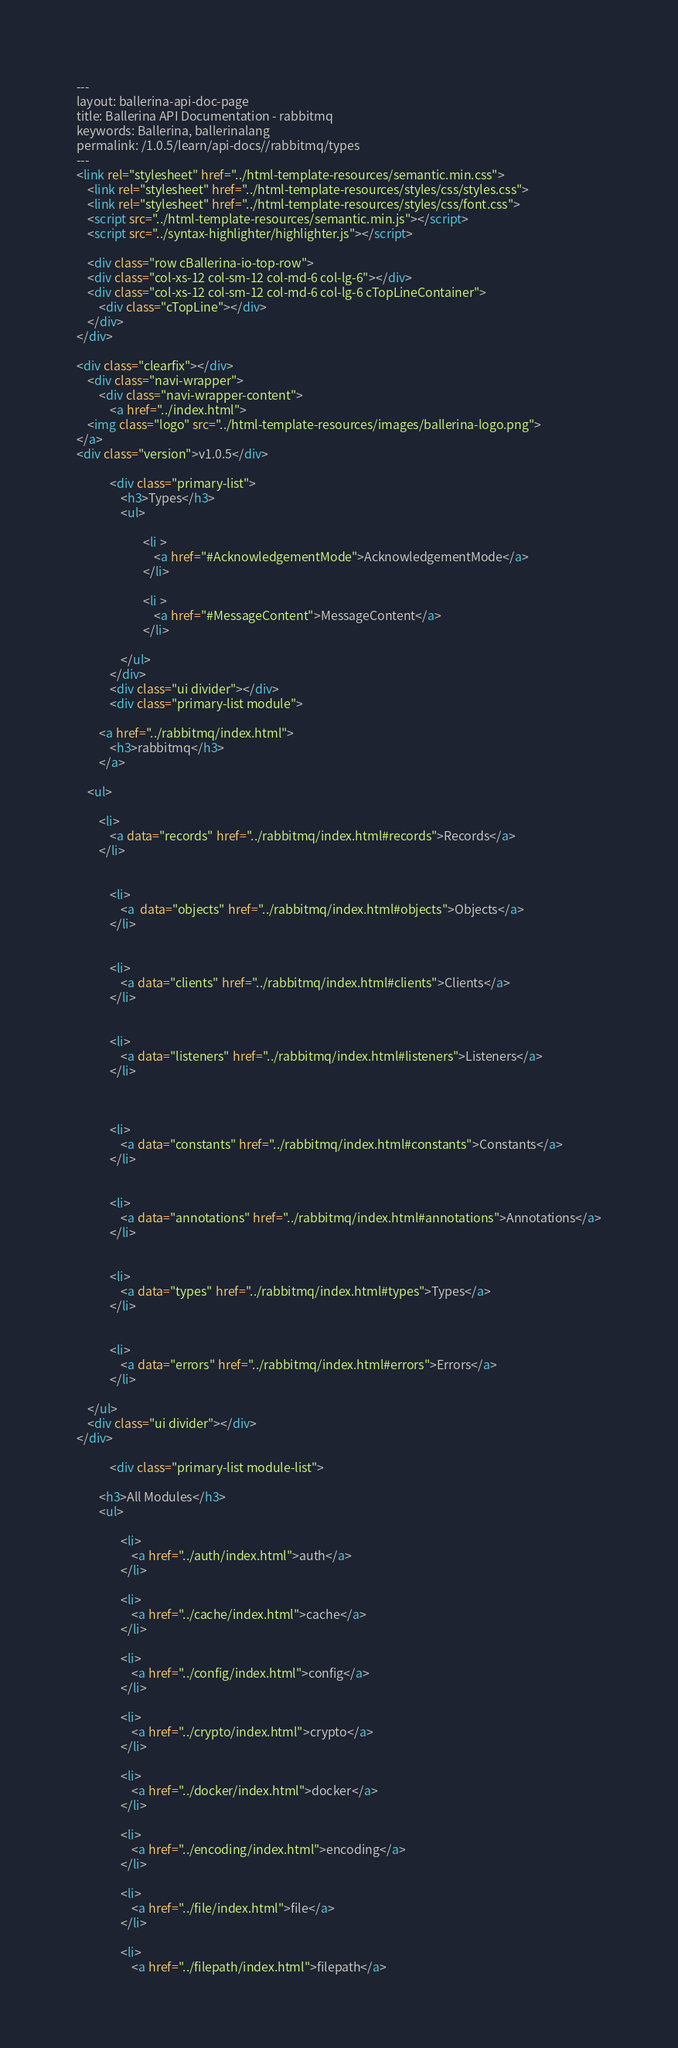<code> <loc_0><loc_0><loc_500><loc_500><_HTML_>---
layout: ballerina-api-doc-page
title: Ballerina API Documentation - rabbitmq
keywords: Ballerina, ballerinalang
permalink: /1.0.5/learn/api-docs//rabbitmq/types
---
<link rel="stylesheet" href="../html-template-resources/semantic.min.css">
    <link rel="stylesheet" href="../html-template-resources/styles/css/styles.css">
    <link rel="stylesheet" href="../html-template-resources/styles/css/font.css">
    <script src="../html-template-resources/semantic.min.js"></script>
    <script src="../syntax-highlighter/highlighter.js"></script>

    <div class="row cBallerina-io-top-row">
    <div class="col-xs-12 col-sm-12 col-md-6 col-lg-6"></div>
    <div class="col-xs-12 col-sm-12 col-md-6 col-lg-6 cTopLineContainer">
        <div class="cTopLine"></div>
    </div>
</div>

<div class="clearfix"></div>
    <div class="navi-wrapper">
        <div class="navi-wrapper-content">
            <a href="../index.html">
    <img class="logo" src="../html-template-resources/images/ballerina-logo.png">
</a>
<div class="version">v1.0.5</div>

            <div class="primary-list">
                <h3>Types</h3>
                <ul>
                    
                        <li >
                            <a href="#AcknowledgementMode">AcknowledgementMode</a>
                        </li>
                    
                        <li >
                            <a href="#MessageContent">MessageContent</a>
                        </li>
                    
                </ul>
            </div>
            <div class="ui divider"></div>
            <div class="primary-list module">
    
        <a href="../rabbitmq/index.html">
            <h3>rabbitmq</h3>
        </a>
    
    <ul>
        
        <li>
            <a data="records" href="../rabbitmq/index.html#records">Records</a>
        </li>
        
        
            <li>
                <a  data="objects" href="../rabbitmq/index.html#objects">Objects</a>
            </li>
        
        
            <li>
                <a data="clients" href="../rabbitmq/index.html#clients">Clients</a>
            </li>
        
        
            <li>
                <a data="listeners" href="../rabbitmq/index.html#listeners">Listeners</a>
            </li>
        
        
        
            <li>
                <a data="constants" href="../rabbitmq/index.html#constants">Constants</a>
            </li>
        
        
            <li>
                <a data="annotations" href="../rabbitmq/index.html#annotations">Annotations</a>
            </li>
        
        
            <li>
                <a data="types" href="../rabbitmq/index.html#types">Types</a>
            </li>
        
        
            <li>
                <a data="errors" href="../rabbitmq/index.html#errors">Errors</a>
            </li>
        
    </ul>
    <div class="ui divider"></div>
</div>

            <div class="primary-list module-list">
    
        <h3>All Modules</h3>
        <ul>
            
                <li>
                    <a href="../auth/index.html">auth</a>
                </li>
            
                <li>
                    <a href="../cache/index.html">cache</a>
                </li>
            
                <li>
                    <a href="../config/index.html">config</a>
                </li>
            
                <li>
                    <a href="../crypto/index.html">crypto</a>
                </li>
            
                <li>
                    <a href="../docker/index.html">docker</a>
                </li>
            
                <li>
                    <a href="../encoding/index.html">encoding</a>
                </li>
            
                <li>
                    <a href="../file/index.html">file</a>
                </li>
            
                <li>
                    <a href="../filepath/index.html">filepath</a></code> 